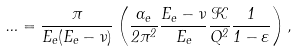<formula> <loc_0><loc_0><loc_500><loc_500>\Phi = \frac { \pi } { E _ { e } ( E _ { e } - \nu ) } \left ( \frac { \alpha _ { e } } { 2 \pi ^ { 2 } } \frac { E _ { e } - \nu } { E _ { e } } \frac { \mathcal { K } } { Q ^ { 2 } } \frac { 1 } { 1 - \varepsilon } \right ) ,</formula> 